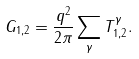<formula> <loc_0><loc_0><loc_500><loc_500>G _ { 1 , 2 } = \frac { q ^ { 2 } } { 2 \pi } \sum _ { \gamma } T ^ { \gamma } _ { 1 , 2 } .</formula> 